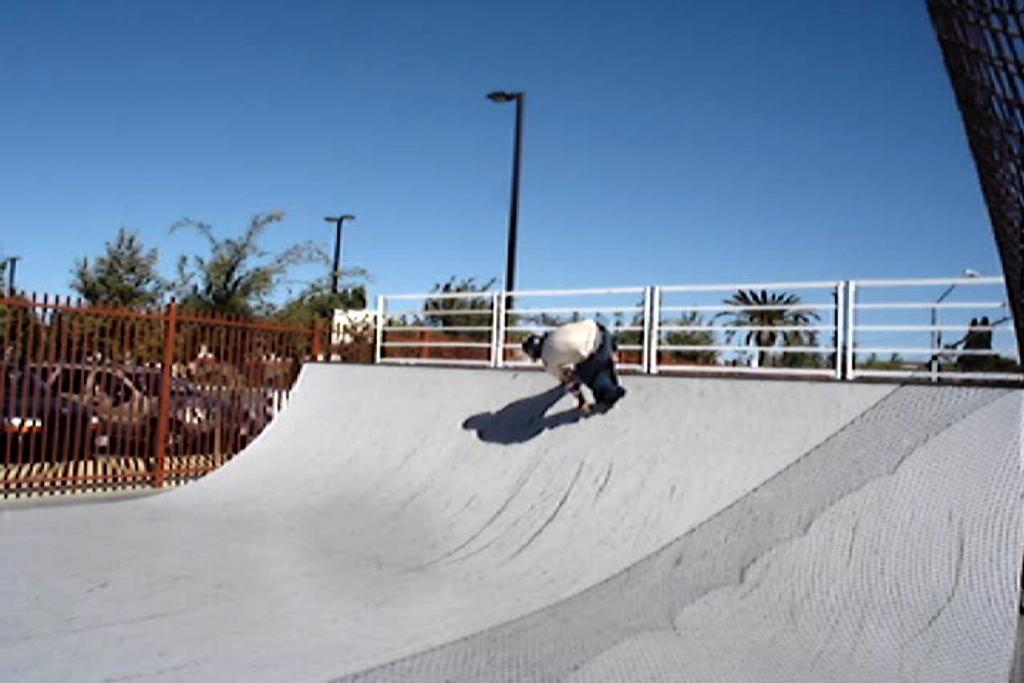Describe this image in one or two sentences. In this image I can see a person visible on skating surface, there is a fence beside the surface there are poles, vehicles , trees, at the top there is the sky visible 